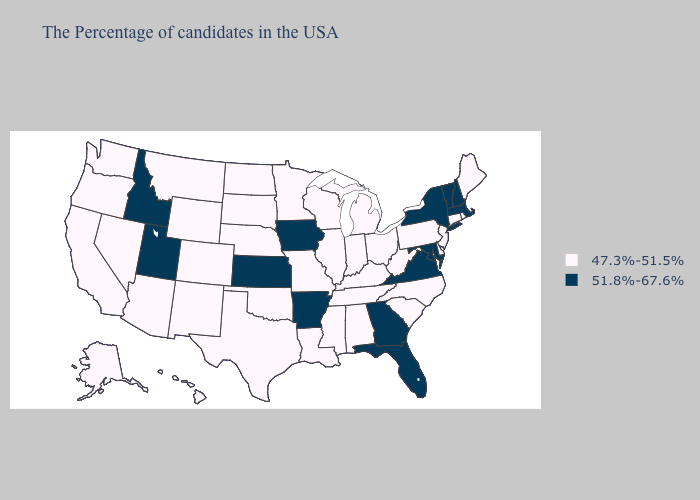Name the states that have a value in the range 51.8%-67.6%?
Concise answer only. Massachusetts, New Hampshire, Vermont, New York, Maryland, Virginia, Florida, Georgia, Arkansas, Iowa, Kansas, Utah, Idaho. Does Nebraska have the lowest value in the MidWest?
Answer briefly. Yes. What is the lowest value in states that border Louisiana?
Write a very short answer. 47.3%-51.5%. Does Iowa have the highest value in the MidWest?
Be succinct. Yes. Does Ohio have the same value as North Dakota?
Keep it brief. Yes. Does Massachusetts have a higher value than Kentucky?
Concise answer only. Yes. Name the states that have a value in the range 51.8%-67.6%?
Quick response, please. Massachusetts, New Hampshire, Vermont, New York, Maryland, Virginia, Florida, Georgia, Arkansas, Iowa, Kansas, Utah, Idaho. Does the first symbol in the legend represent the smallest category?
Concise answer only. Yes. Is the legend a continuous bar?
Answer briefly. No. Does Montana have the same value as Rhode Island?
Write a very short answer. Yes. Which states have the highest value in the USA?
Write a very short answer. Massachusetts, New Hampshire, Vermont, New York, Maryland, Virginia, Florida, Georgia, Arkansas, Iowa, Kansas, Utah, Idaho. Does the first symbol in the legend represent the smallest category?
Answer briefly. Yes. Among the states that border New York , does Connecticut have the highest value?
Write a very short answer. No. What is the lowest value in the MidWest?
Write a very short answer. 47.3%-51.5%. Which states have the lowest value in the USA?
Be succinct. Maine, Rhode Island, Connecticut, New Jersey, Delaware, Pennsylvania, North Carolina, South Carolina, West Virginia, Ohio, Michigan, Kentucky, Indiana, Alabama, Tennessee, Wisconsin, Illinois, Mississippi, Louisiana, Missouri, Minnesota, Nebraska, Oklahoma, Texas, South Dakota, North Dakota, Wyoming, Colorado, New Mexico, Montana, Arizona, Nevada, California, Washington, Oregon, Alaska, Hawaii. 